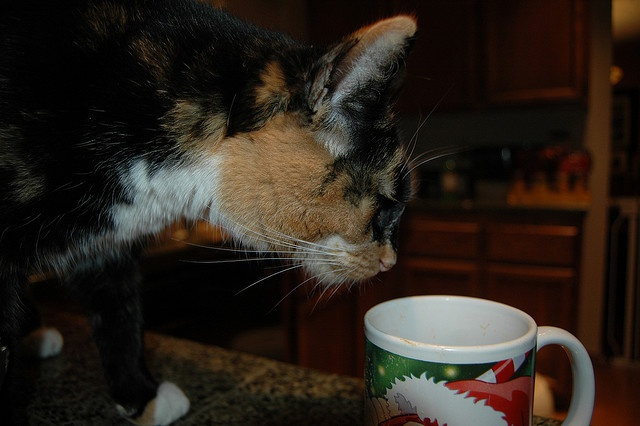Describe the objects in this image and their specific colors. I can see cat in black and gray tones and cup in black, darkgray, gray, and maroon tones in this image. 